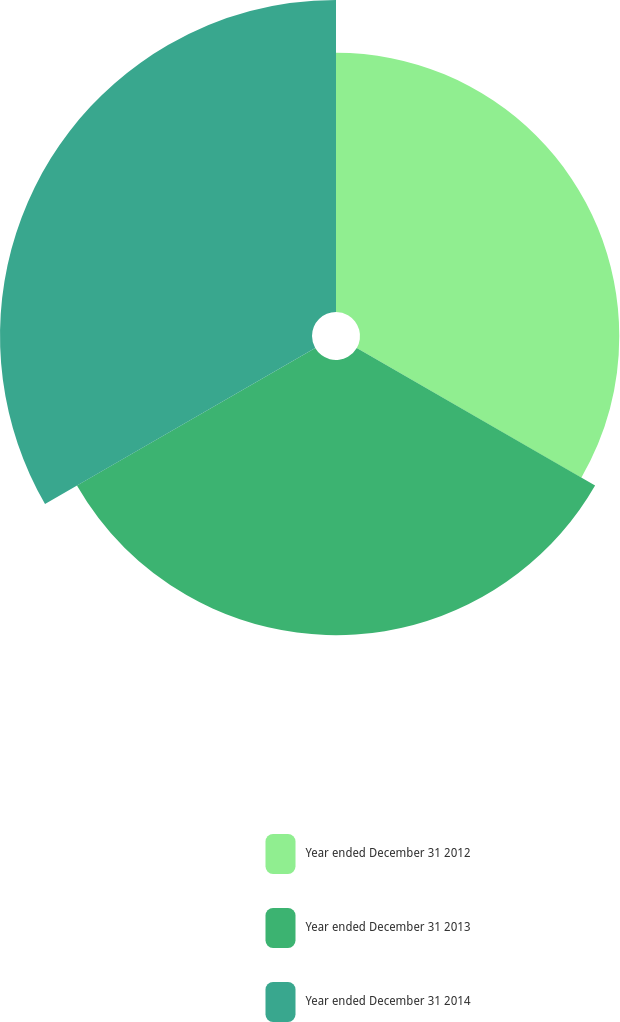Convert chart to OTSL. <chart><loc_0><loc_0><loc_500><loc_500><pie_chart><fcel>Year ended December 31 2012<fcel>Year ended December 31 2013<fcel>Year ended December 31 2014<nl><fcel>30.63%<fcel>32.51%<fcel>36.86%<nl></chart> 